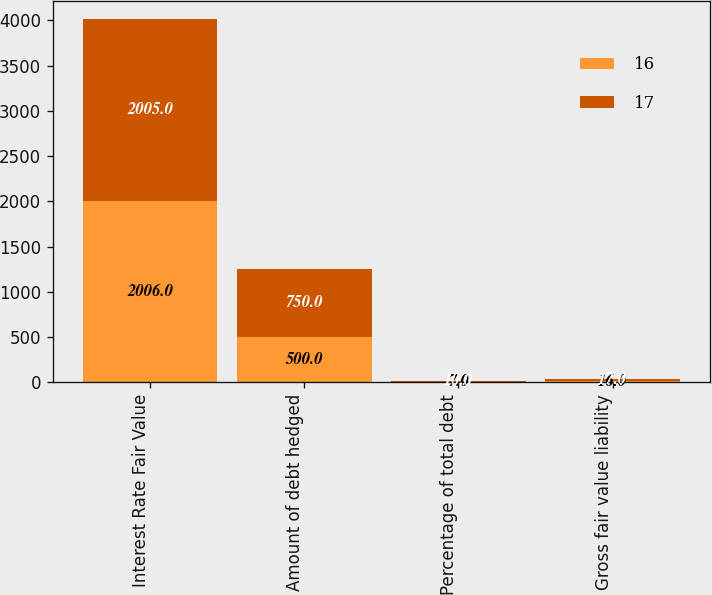Convert chart to OTSL. <chart><loc_0><loc_0><loc_500><loc_500><stacked_bar_chart><ecel><fcel>Interest Rate Fair Value<fcel>Amount of debt hedged<fcel>Percentage of total debt<fcel>Gross fair value liability<nl><fcel>16<fcel>2006<fcel>500<fcel>7<fcel>16<nl><fcel>17<fcel>2005<fcel>750<fcel>10<fcel>17<nl></chart> 